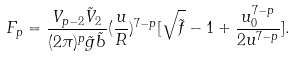Convert formula to latex. <formula><loc_0><loc_0><loc_500><loc_500>F _ { p } = \frac { V _ { p - 2 } \tilde { V } _ { 2 } } { ( 2 \pi ) ^ { p } \tilde { g } \tilde { b } } ( \frac { u } { R } ) ^ { 7 - p } [ \sqrt { \tilde { f } } - 1 + \frac { u _ { 0 } ^ { 7 - p } } { 2 u ^ { 7 - p } } ] .</formula> 